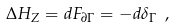Convert formula to latex. <formula><loc_0><loc_0><loc_500><loc_500>\Delta H _ { Z } = d F _ { \partial \Gamma } = - d \delta _ { \Gamma } \ ,</formula> 